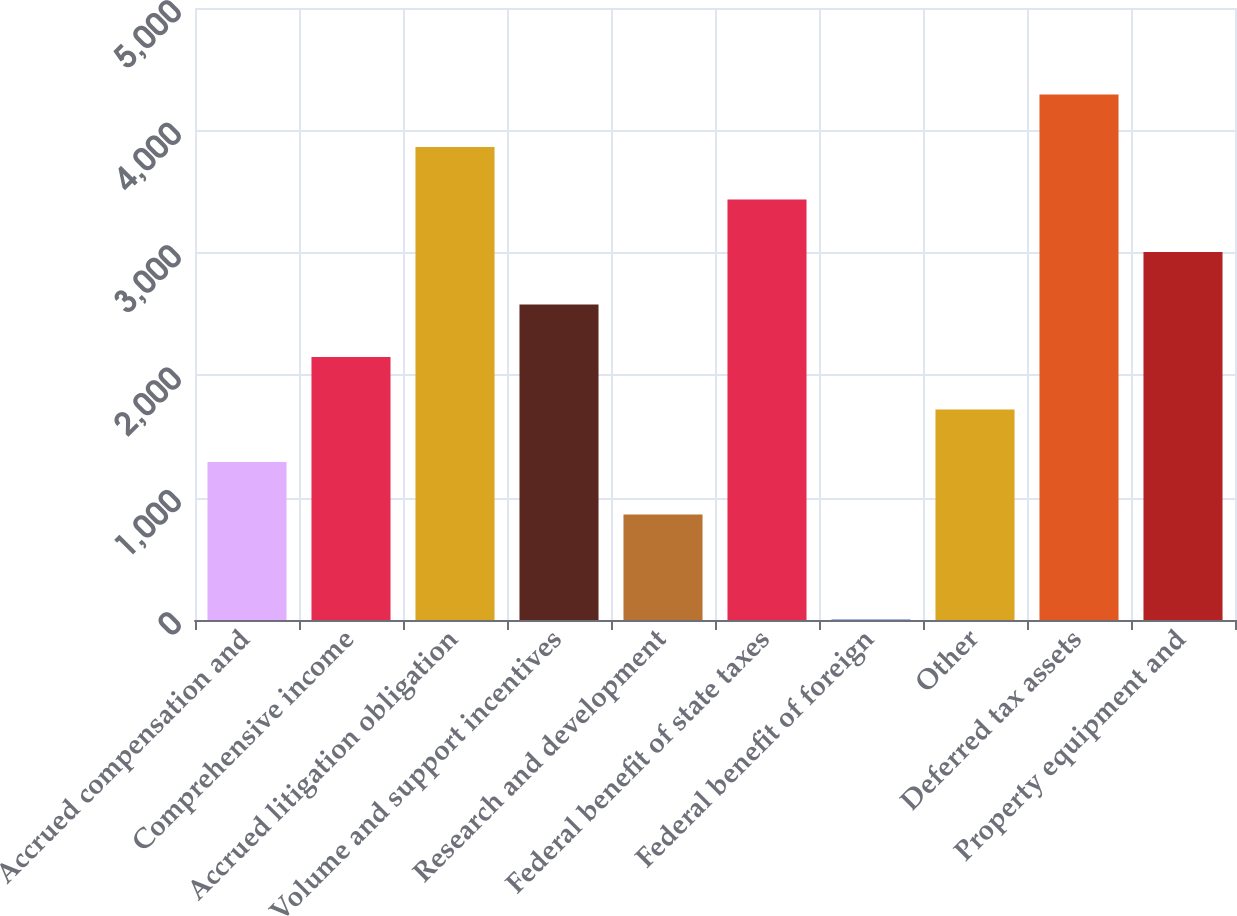<chart> <loc_0><loc_0><loc_500><loc_500><bar_chart><fcel>Accrued compensation and<fcel>Comprehensive income<fcel>Accrued litigation obligation<fcel>Volume and support incentives<fcel>Research and development<fcel>Federal benefit of state taxes<fcel>Federal benefit of foreign<fcel>Other<fcel>Deferred tax assets<fcel>Property equipment and<nl><fcel>1291.7<fcel>2149.5<fcel>3865.1<fcel>2578.4<fcel>862.8<fcel>3436.2<fcel>5<fcel>1720.6<fcel>4294<fcel>3007.3<nl></chart> 